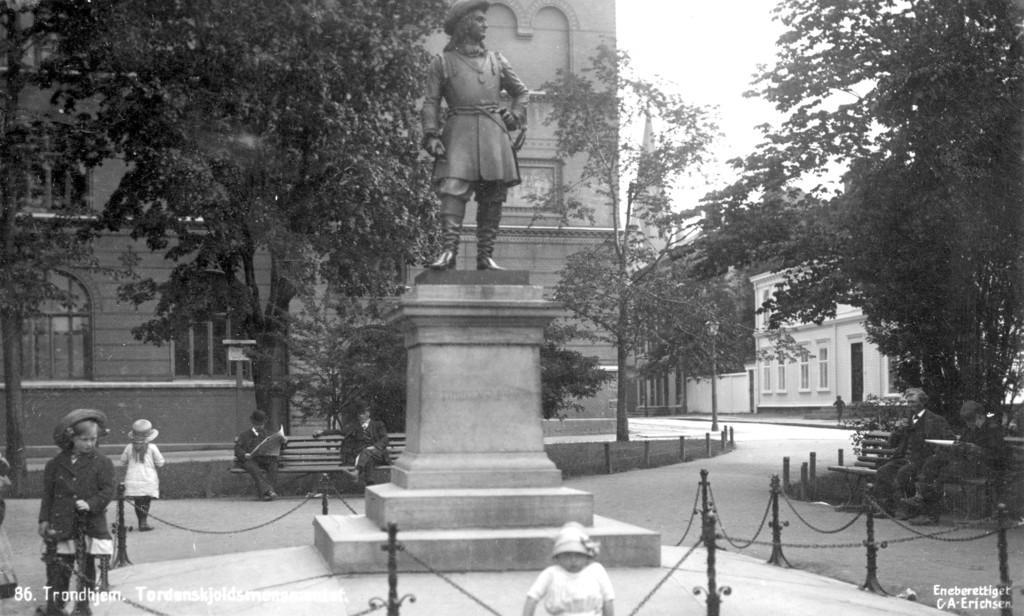Could you give a brief overview of what you see in this image? In this picture there are buildings and trees. In the foreground there is a statue and there is a railing. There are group of people. At the top there is sky. At the bottom there is a road. At the bottom left and at the bottom right there is text. 